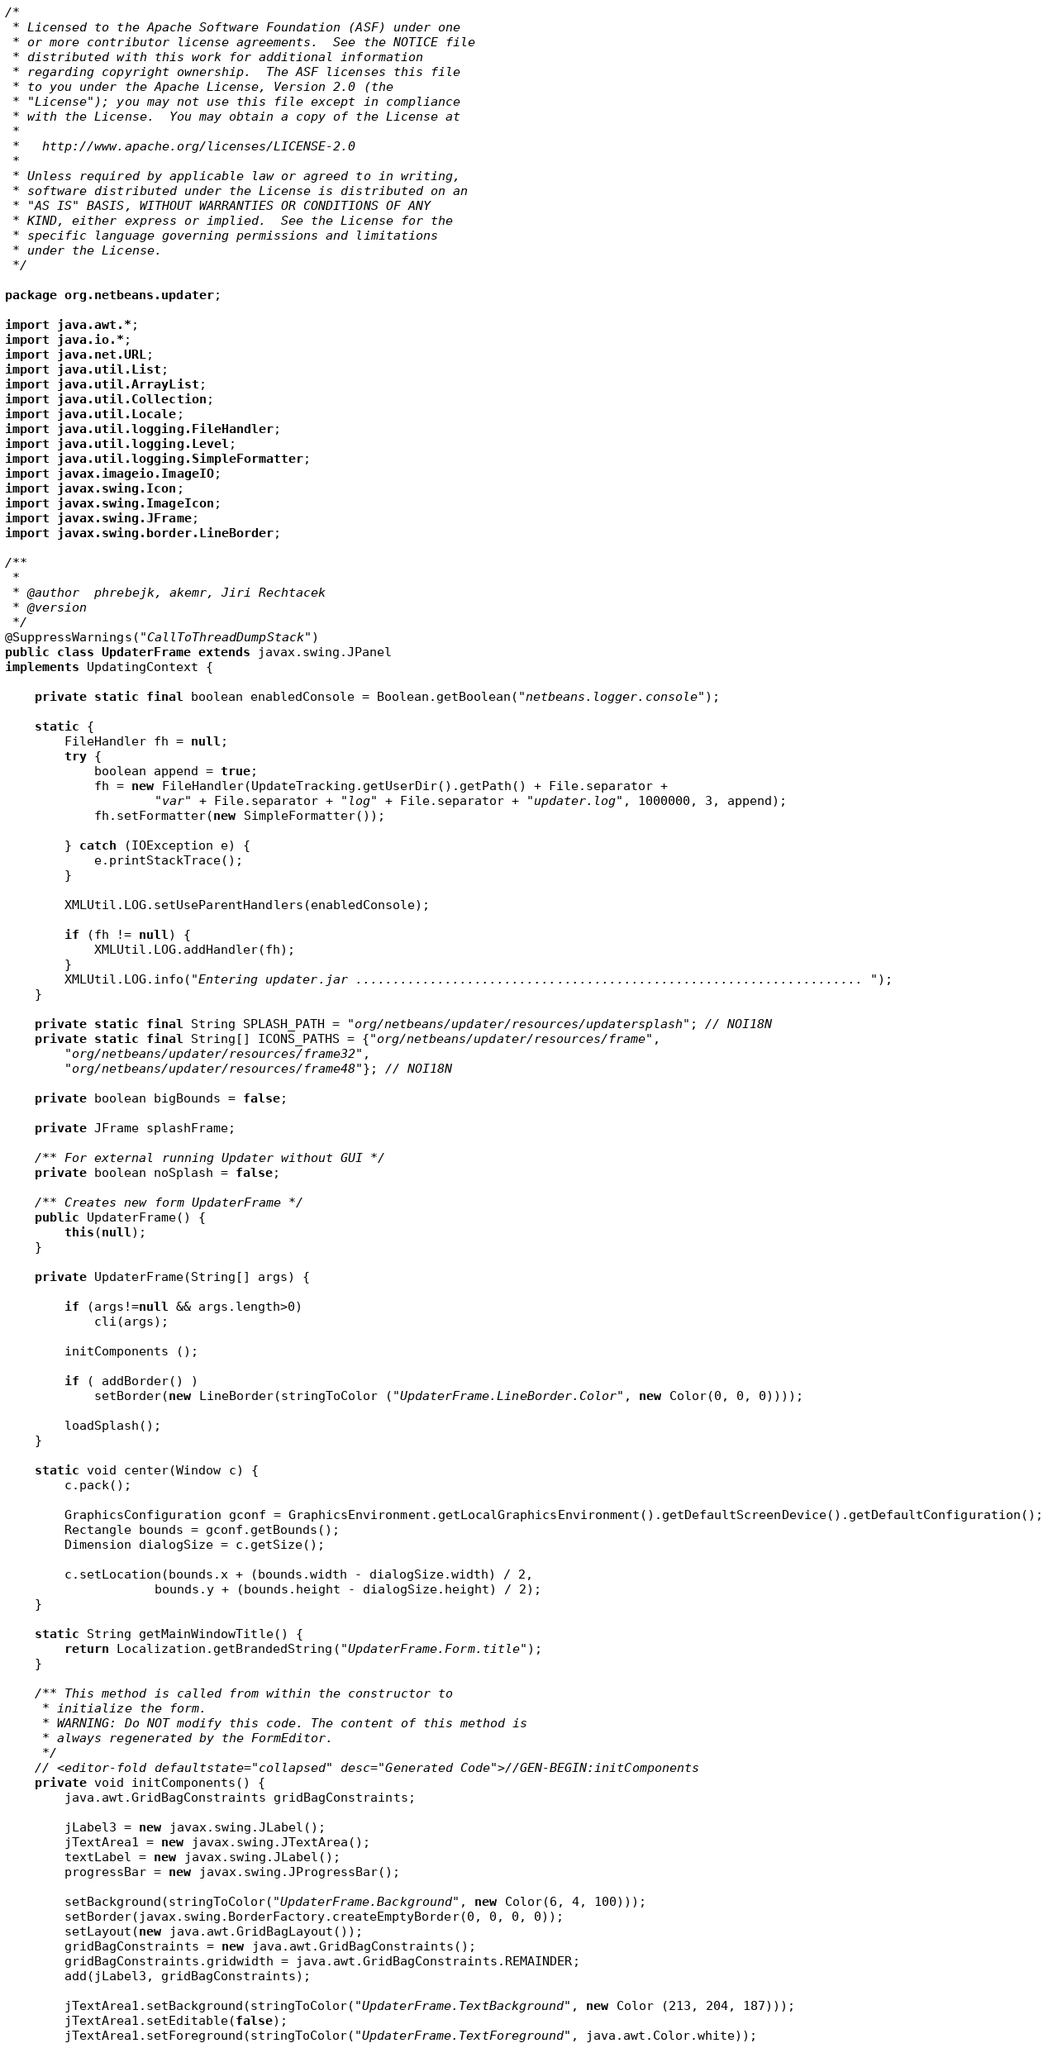Convert code to text. <code><loc_0><loc_0><loc_500><loc_500><_Java_>/*
 * Licensed to the Apache Software Foundation (ASF) under one
 * or more contributor license agreements.  See the NOTICE file
 * distributed with this work for additional information
 * regarding copyright ownership.  The ASF licenses this file
 * to you under the Apache License, Version 2.0 (the
 * "License"); you may not use this file except in compliance
 * with the License.  You may obtain a copy of the License at
 *
 *   http://www.apache.org/licenses/LICENSE-2.0
 *
 * Unless required by applicable law or agreed to in writing,
 * software distributed under the License is distributed on an
 * "AS IS" BASIS, WITHOUT WARRANTIES OR CONDITIONS OF ANY
 * KIND, either express or implied.  See the License for the
 * specific language governing permissions and limitations
 * under the License.
 */

package org.netbeans.updater;

import java.awt.*;
import java.io.*;
import java.net.URL;
import java.util.List;
import java.util.ArrayList;
import java.util.Collection;
import java.util.Locale;
import java.util.logging.FileHandler;
import java.util.logging.Level;
import java.util.logging.SimpleFormatter;
import javax.imageio.ImageIO;
import javax.swing.Icon;
import javax.swing.ImageIcon;
import javax.swing.JFrame;
import javax.swing.border.LineBorder;

/**
 *
 * @author  phrebejk, akemr, Jiri Rechtacek
 * @version
 */
@SuppressWarnings("CallToThreadDumpStack")
public class UpdaterFrame extends javax.swing.JPanel 
implements UpdatingContext {

    private static final boolean enabledConsole = Boolean.getBoolean("netbeans.logger.console");
    
    static {
        FileHandler fh = null;
        try {
            boolean append = true;
            fh = new FileHandler(UpdateTracking.getUserDir().getPath() + File.separator +
                    "var" + File.separator + "log" + File.separator + "updater.log", 1000000, 3, append);
            fh.setFormatter(new SimpleFormatter());

        } catch (IOException e) {
            e.printStackTrace();
        }
        
        XMLUtil.LOG.setUseParentHandlers(enabledConsole);
        
        if (fh != null) {
            XMLUtil.LOG.addHandler(fh);
        }
        XMLUtil.LOG.info("Entering updater.jar .................................................................... ");
    }
    
    private static final String SPLASH_PATH = "org/netbeans/updater/resources/updatersplash"; // NOI18N
    private static final String[] ICONS_PATHS = {"org/netbeans/updater/resources/frame",
        "org/netbeans/updater/resources/frame32",
        "org/netbeans/updater/resources/frame48"}; // NOI18N

    private boolean bigBounds = false;

    private JFrame splashFrame;
    
    /** For external running Updater without GUI */
    private boolean noSplash = false; 
    
    /** Creates new form UpdaterFrame */
    public UpdaterFrame() {
        this(null);
    }
    
    private UpdaterFrame(String[] args) {
        
        if (args!=null && args.length>0)
            cli(args);
        
        initComponents ();
        
        if ( addBorder() )
            setBorder(new LineBorder(stringToColor ("UpdaterFrame.LineBorder.Color", new Color(0, 0, 0))));
        
        loadSplash();
    }
    
    static void center(Window c) {
        c.pack();

        GraphicsConfiguration gconf = GraphicsEnvironment.getLocalGraphicsEnvironment().getDefaultScreenDevice().getDefaultConfiguration();
        Rectangle bounds = gconf.getBounds();
        Dimension dialogSize = c.getSize();
        
        c.setLocation(bounds.x + (bounds.width - dialogSize.width) / 2,
                    bounds.y + (bounds.height - dialogSize.height) / 2);
    }

    static String getMainWindowTitle() {
        return Localization.getBrandedString("UpdaterFrame.Form.title");
    }
    
    /** This method is called from within the constructor to
     * initialize the form.
     * WARNING: Do NOT modify this code. The content of this method is
     * always regenerated by the FormEditor.
     */
    // <editor-fold defaultstate="collapsed" desc="Generated Code">//GEN-BEGIN:initComponents
    private void initComponents() {
        java.awt.GridBagConstraints gridBagConstraints;

        jLabel3 = new javax.swing.JLabel();
        jTextArea1 = new javax.swing.JTextArea();
        textLabel = new javax.swing.JLabel();
        progressBar = new javax.swing.JProgressBar();

        setBackground(stringToColor("UpdaterFrame.Background", new Color(6, 4, 100)));
        setBorder(javax.swing.BorderFactory.createEmptyBorder(0, 0, 0, 0));
        setLayout(new java.awt.GridBagLayout());
        gridBagConstraints = new java.awt.GridBagConstraints();
        gridBagConstraints.gridwidth = java.awt.GridBagConstraints.REMAINDER;
        add(jLabel3, gridBagConstraints);

        jTextArea1.setBackground(stringToColor("UpdaterFrame.TextBackground", new Color (213, 204, 187)));
        jTextArea1.setEditable(false);
        jTextArea1.setForeground(stringToColor("UpdaterFrame.TextForeground", java.awt.Color.white));</code> 